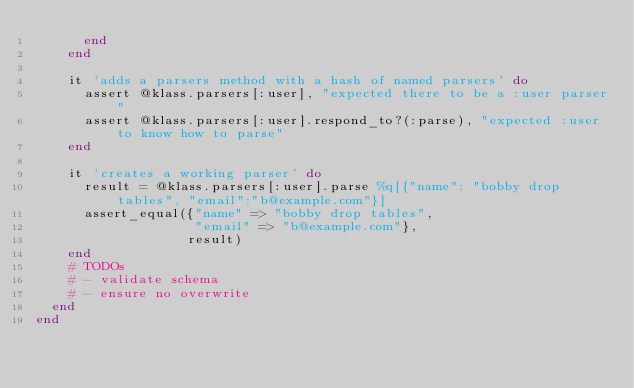Convert code to text. <code><loc_0><loc_0><loc_500><loc_500><_Ruby_>      end
    end

    it 'adds a parsers method with a hash of named parsers' do
      assert @klass.parsers[:user], "expected there to be a :user parser"
      assert @klass.parsers[:user].respond_to?(:parse), "expected :user to know how to parse"
    end

    it 'creates a working parser' do
      result = @klass.parsers[:user].parse %q[{"name": "bobby drop tables", "email":"b@example.com"}]
      assert_equal({"name" => "bobby drop tables",
                    "email" => "b@example.com"},
                   result)
    end
    # TODOs
    # - validate schema
    # - ensure no overwrite
  end
end</code> 